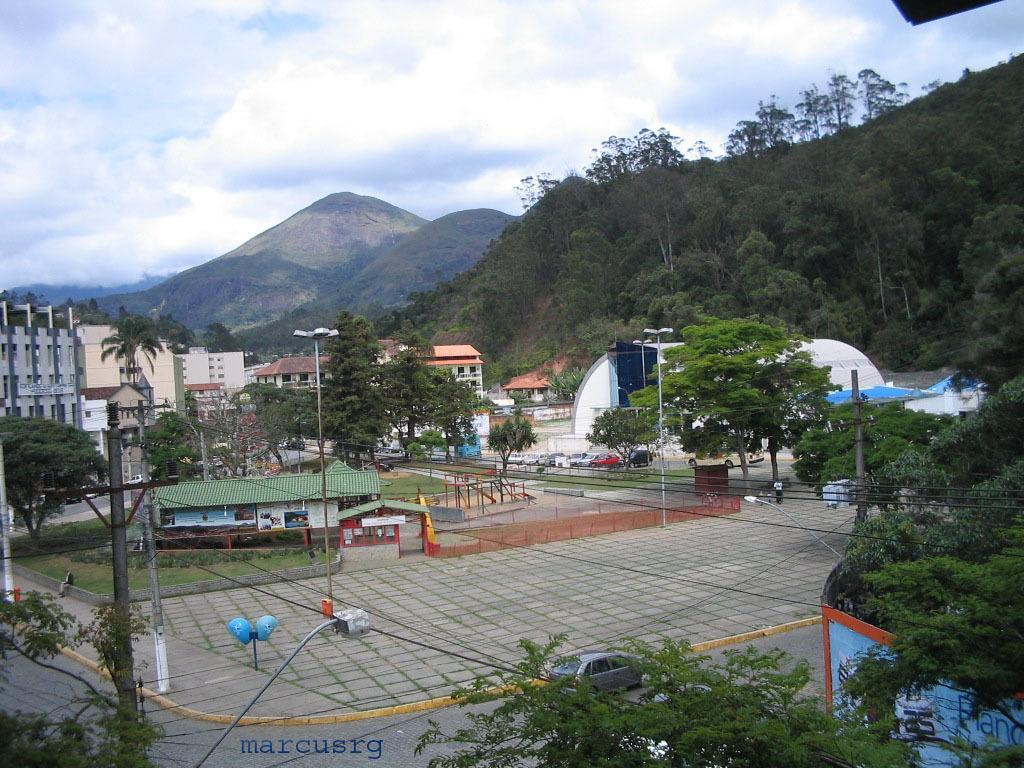In one or two sentences, can you explain what this image depicts? In this picture we can see poles, wires, trees, lights, board, houses and walls. There is a person sitting and we can see car and grass. In the background of the image we can see vehicles, buildings, trees, hills and sky with clouds. 